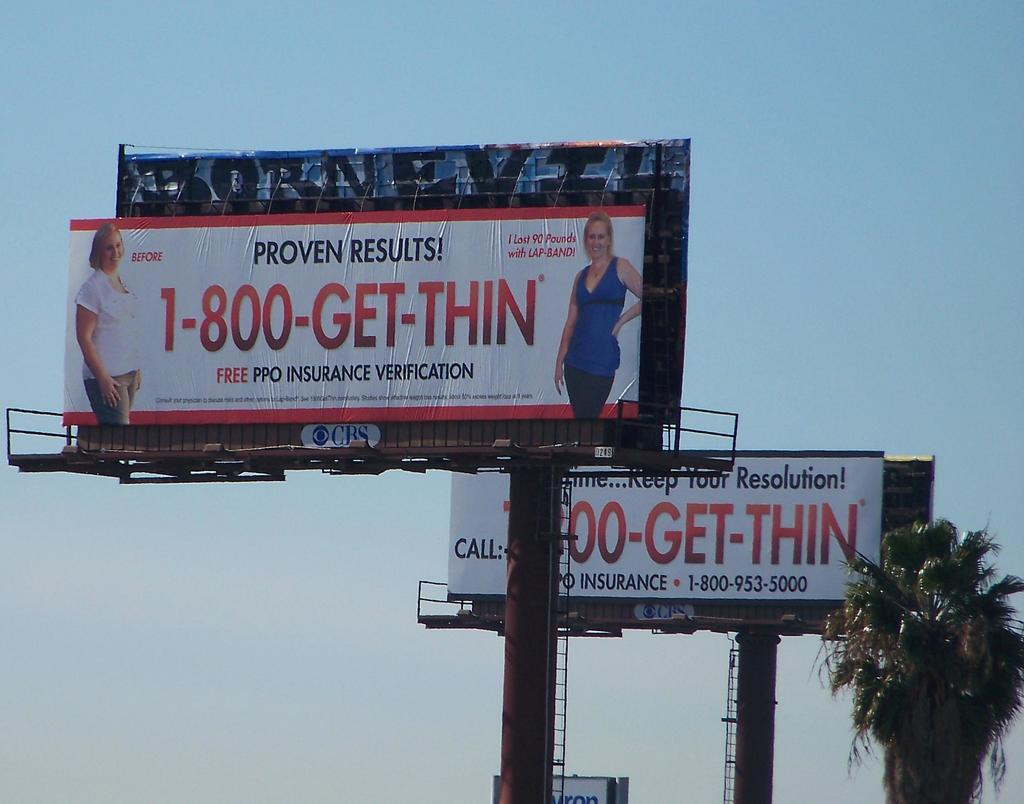<image>
Relay a brief, clear account of the picture shown. Heavyset people can call 1-800-GET-THIN in order to lose weight and enjoy proven results. 